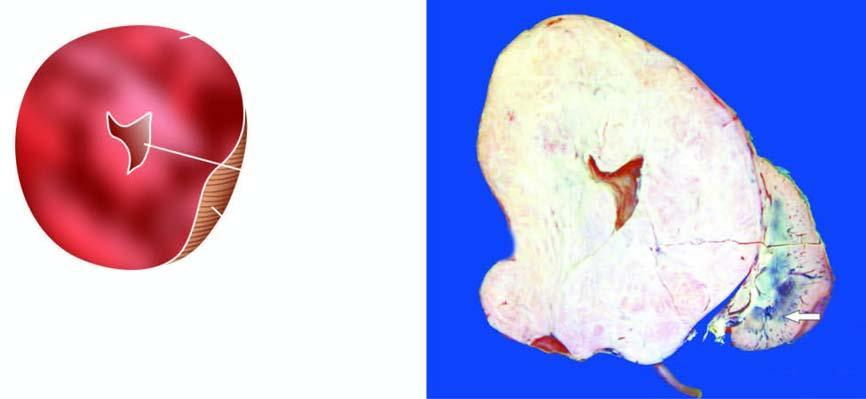what shows replacement of almost whole kidney by the tumour leaving a thin strip of compressed renal tissue at lower end?
Answer the question using a single word or phrase. Sectioned surface 